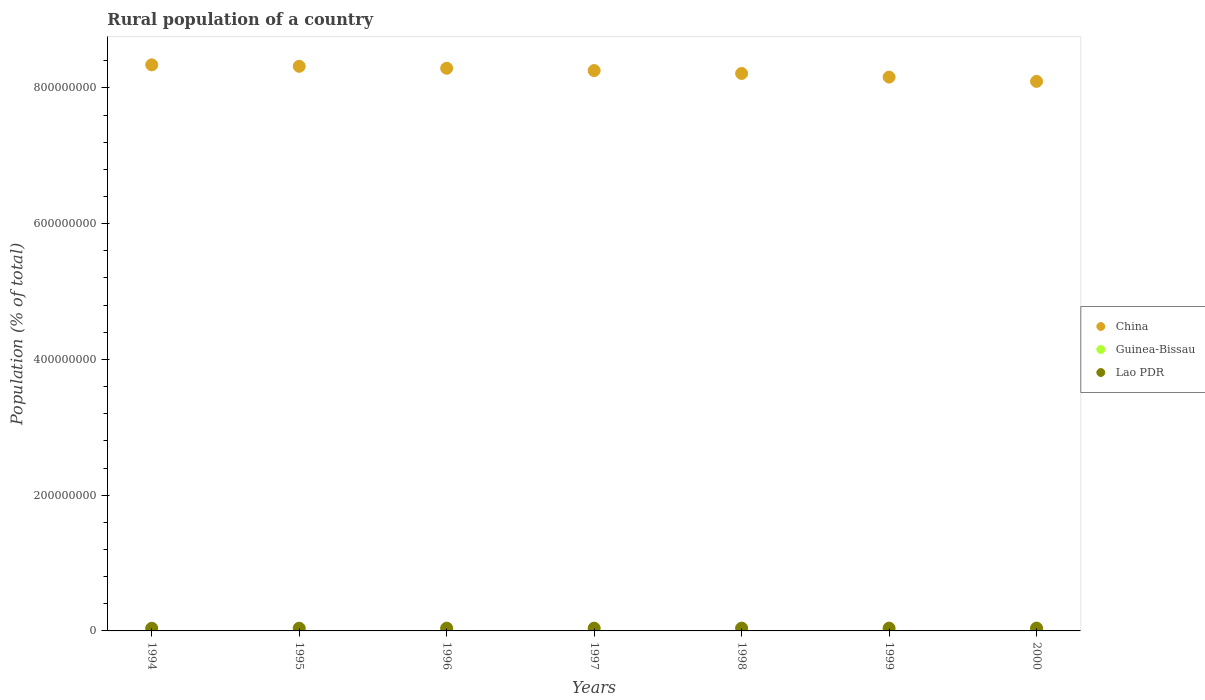Is the number of dotlines equal to the number of legend labels?
Offer a terse response. Yes. What is the rural population in China in 1999?
Your response must be concise. 8.16e+08. Across all years, what is the maximum rural population in Guinea-Bissau?
Keep it short and to the point. 8.33e+05. Across all years, what is the minimum rural population in Lao PDR?
Provide a short and direct response. 3.94e+06. In which year was the rural population in Lao PDR minimum?
Offer a very short reply. 1994. What is the total rural population in China in the graph?
Your response must be concise. 5.77e+09. What is the difference between the rural population in China in 1996 and that in 1999?
Ensure brevity in your answer.  1.30e+07. What is the difference between the rural population in Lao PDR in 1998 and the rural population in China in 1999?
Provide a short and direct response. -8.12e+08. What is the average rural population in Guinea-Bissau per year?
Ensure brevity in your answer.  8.11e+05. In the year 1994, what is the difference between the rural population in Guinea-Bissau and rural population in China?
Ensure brevity in your answer.  -8.33e+08. In how many years, is the rural population in China greater than 560000000 %?
Give a very brief answer. 7. What is the ratio of the rural population in Guinea-Bissau in 1998 to that in 2000?
Your answer should be very brief. 0.98. What is the difference between the highest and the second highest rural population in Lao PDR?
Provide a succinct answer. 1.58e+04. What is the difference between the highest and the lowest rural population in Guinea-Bissau?
Ensure brevity in your answer.  4.62e+04. Is the sum of the rural population in Guinea-Bissau in 1997 and 1999 greater than the maximum rural population in China across all years?
Keep it short and to the point. No. Is it the case that in every year, the sum of the rural population in Lao PDR and rural population in Guinea-Bissau  is greater than the rural population in China?
Your response must be concise. No. Does the rural population in Lao PDR monotonically increase over the years?
Make the answer very short. Yes. Is the rural population in Lao PDR strictly less than the rural population in Guinea-Bissau over the years?
Offer a terse response. No. How many dotlines are there?
Offer a terse response. 3. Does the graph contain grids?
Provide a succinct answer. No. Where does the legend appear in the graph?
Provide a short and direct response. Center right. What is the title of the graph?
Keep it short and to the point. Rural population of a country. Does "Tanzania" appear as one of the legend labels in the graph?
Give a very brief answer. No. What is the label or title of the Y-axis?
Your answer should be compact. Population (% of total). What is the Population (% of total) in China in 1994?
Make the answer very short. 8.34e+08. What is the Population (% of total) of Guinea-Bissau in 1994?
Offer a very short reply. 7.87e+05. What is the Population (% of total) of Lao PDR in 1994?
Provide a short and direct response. 3.94e+06. What is the Population (% of total) of China in 1995?
Offer a very short reply. 8.32e+08. What is the Population (% of total) in Guinea-Bissau in 1995?
Make the answer very short. 7.96e+05. What is the Population (% of total) of Lao PDR in 1995?
Ensure brevity in your answer.  4.01e+06. What is the Population (% of total) in China in 1996?
Your answer should be compact. 8.29e+08. What is the Population (% of total) of Guinea-Bissau in 1996?
Provide a succinct answer. 8.04e+05. What is the Population (% of total) in Lao PDR in 1996?
Provide a succinct answer. 4.06e+06. What is the Population (% of total) of China in 1997?
Your answer should be compact. 8.26e+08. What is the Population (% of total) of Guinea-Bissau in 1997?
Give a very brief answer. 8.11e+05. What is the Population (% of total) of Lao PDR in 1997?
Your answer should be compact. 4.10e+06. What is the Population (% of total) in China in 1998?
Your response must be concise. 8.21e+08. What is the Population (% of total) of Guinea-Bissau in 1998?
Your response must be concise. 8.19e+05. What is the Population (% of total) of Lao PDR in 1998?
Provide a succinct answer. 4.13e+06. What is the Population (% of total) of China in 1999?
Provide a short and direct response. 8.16e+08. What is the Population (% of total) of Guinea-Bissau in 1999?
Your answer should be very brief. 8.26e+05. What is the Population (% of total) in Lao PDR in 1999?
Offer a very short reply. 4.15e+06. What is the Population (% of total) in China in 2000?
Keep it short and to the point. 8.10e+08. What is the Population (% of total) of Guinea-Bissau in 2000?
Make the answer very short. 8.33e+05. What is the Population (% of total) of Lao PDR in 2000?
Give a very brief answer. 4.17e+06. Across all years, what is the maximum Population (% of total) of China?
Your answer should be very brief. 8.34e+08. Across all years, what is the maximum Population (% of total) in Guinea-Bissau?
Your answer should be very brief. 8.33e+05. Across all years, what is the maximum Population (% of total) of Lao PDR?
Your answer should be very brief. 4.17e+06. Across all years, what is the minimum Population (% of total) in China?
Offer a very short reply. 8.10e+08. Across all years, what is the minimum Population (% of total) in Guinea-Bissau?
Your response must be concise. 7.87e+05. Across all years, what is the minimum Population (% of total) of Lao PDR?
Give a very brief answer. 3.94e+06. What is the total Population (% of total) of China in the graph?
Ensure brevity in your answer.  5.77e+09. What is the total Population (% of total) of Guinea-Bissau in the graph?
Ensure brevity in your answer.  5.68e+06. What is the total Population (% of total) in Lao PDR in the graph?
Ensure brevity in your answer.  2.86e+07. What is the difference between the Population (% of total) in China in 1994 and that in 1995?
Your answer should be compact. 2.18e+06. What is the difference between the Population (% of total) in Guinea-Bissau in 1994 and that in 1995?
Your answer should be compact. -8394. What is the difference between the Population (% of total) in Lao PDR in 1994 and that in 1995?
Provide a short and direct response. -7.02e+04. What is the difference between the Population (% of total) in China in 1994 and that in 1996?
Your response must be concise. 5.04e+06. What is the difference between the Population (% of total) in Guinea-Bissau in 1994 and that in 1996?
Give a very brief answer. -1.65e+04. What is the difference between the Population (% of total) in Lao PDR in 1994 and that in 1996?
Provide a succinct answer. -1.17e+05. What is the difference between the Population (% of total) in China in 1994 and that in 1997?
Your response must be concise. 8.41e+06. What is the difference between the Population (% of total) in Guinea-Bissau in 1994 and that in 1997?
Your response must be concise. -2.43e+04. What is the difference between the Population (% of total) of Lao PDR in 1994 and that in 1997?
Give a very brief answer. -1.56e+05. What is the difference between the Population (% of total) of China in 1994 and that in 1998?
Your answer should be compact. 1.27e+07. What is the difference between the Population (% of total) of Guinea-Bissau in 1994 and that in 1998?
Keep it short and to the point. -3.19e+04. What is the difference between the Population (% of total) of Lao PDR in 1994 and that in 1998?
Offer a terse response. -1.87e+05. What is the difference between the Population (% of total) of China in 1994 and that in 1999?
Offer a terse response. 1.80e+07. What is the difference between the Population (% of total) in Guinea-Bissau in 1994 and that in 1999?
Make the answer very short. -3.92e+04. What is the difference between the Population (% of total) in Lao PDR in 1994 and that in 1999?
Provide a short and direct response. -2.10e+05. What is the difference between the Population (% of total) in China in 1994 and that in 2000?
Your answer should be very brief. 2.44e+07. What is the difference between the Population (% of total) of Guinea-Bissau in 1994 and that in 2000?
Offer a terse response. -4.62e+04. What is the difference between the Population (% of total) of Lao PDR in 1994 and that in 2000?
Your answer should be compact. -2.25e+05. What is the difference between the Population (% of total) in China in 1995 and that in 1996?
Offer a terse response. 2.86e+06. What is the difference between the Population (% of total) of Guinea-Bissau in 1995 and that in 1996?
Provide a succinct answer. -8104. What is the difference between the Population (% of total) of Lao PDR in 1995 and that in 1996?
Give a very brief answer. -4.72e+04. What is the difference between the Population (% of total) in China in 1995 and that in 1997?
Your answer should be compact. 6.23e+06. What is the difference between the Population (% of total) in Guinea-Bissau in 1995 and that in 1997?
Make the answer very short. -1.60e+04. What is the difference between the Population (% of total) in Lao PDR in 1995 and that in 1997?
Make the answer very short. -8.59e+04. What is the difference between the Population (% of total) in China in 1995 and that in 1998?
Ensure brevity in your answer.  1.05e+07. What is the difference between the Population (% of total) of Guinea-Bissau in 1995 and that in 1998?
Offer a very short reply. -2.35e+04. What is the difference between the Population (% of total) in Lao PDR in 1995 and that in 1998?
Ensure brevity in your answer.  -1.16e+05. What is the difference between the Population (% of total) of China in 1995 and that in 1999?
Your answer should be very brief. 1.59e+07. What is the difference between the Population (% of total) of Guinea-Bissau in 1995 and that in 1999?
Offer a terse response. -3.08e+04. What is the difference between the Population (% of total) in Lao PDR in 1995 and that in 1999?
Keep it short and to the point. -1.39e+05. What is the difference between the Population (% of total) in China in 1995 and that in 2000?
Provide a succinct answer. 2.22e+07. What is the difference between the Population (% of total) of Guinea-Bissau in 1995 and that in 2000?
Make the answer very short. -3.78e+04. What is the difference between the Population (% of total) in Lao PDR in 1995 and that in 2000?
Provide a succinct answer. -1.55e+05. What is the difference between the Population (% of total) of China in 1996 and that in 1997?
Provide a short and direct response. 3.37e+06. What is the difference between the Population (% of total) in Guinea-Bissau in 1996 and that in 1997?
Offer a terse response. -7846. What is the difference between the Population (% of total) of Lao PDR in 1996 and that in 1997?
Your answer should be very brief. -3.88e+04. What is the difference between the Population (% of total) of China in 1996 and that in 1998?
Keep it short and to the point. 7.63e+06. What is the difference between the Population (% of total) in Guinea-Bissau in 1996 and that in 1998?
Your answer should be compact. -1.54e+04. What is the difference between the Population (% of total) in Lao PDR in 1996 and that in 1998?
Your response must be concise. -6.93e+04. What is the difference between the Population (% of total) of China in 1996 and that in 1999?
Offer a very short reply. 1.30e+07. What is the difference between the Population (% of total) of Guinea-Bissau in 1996 and that in 1999?
Make the answer very short. -2.27e+04. What is the difference between the Population (% of total) in Lao PDR in 1996 and that in 1999?
Provide a succinct answer. -9.21e+04. What is the difference between the Population (% of total) in China in 1996 and that in 2000?
Offer a terse response. 1.93e+07. What is the difference between the Population (% of total) of Guinea-Bissau in 1996 and that in 2000?
Your response must be concise. -2.97e+04. What is the difference between the Population (% of total) in Lao PDR in 1996 and that in 2000?
Offer a terse response. -1.08e+05. What is the difference between the Population (% of total) in China in 1997 and that in 1998?
Offer a terse response. 4.26e+06. What is the difference between the Population (% of total) of Guinea-Bissau in 1997 and that in 1998?
Provide a succinct answer. -7565. What is the difference between the Population (% of total) in Lao PDR in 1997 and that in 1998?
Give a very brief answer. -3.05e+04. What is the difference between the Population (% of total) of China in 1997 and that in 1999?
Offer a very short reply. 9.62e+06. What is the difference between the Population (% of total) of Guinea-Bissau in 1997 and that in 1999?
Provide a succinct answer. -1.48e+04. What is the difference between the Population (% of total) of Lao PDR in 1997 and that in 1999?
Offer a very short reply. -5.33e+04. What is the difference between the Population (% of total) of China in 1997 and that in 2000?
Provide a short and direct response. 1.59e+07. What is the difference between the Population (% of total) in Guinea-Bissau in 1997 and that in 2000?
Ensure brevity in your answer.  -2.18e+04. What is the difference between the Population (% of total) in Lao PDR in 1997 and that in 2000?
Provide a succinct answer. -6.91e+04. What is the difference between the Population (% of total) of China in 1998 and that in 1999?
Ensure brevity in your answer.  5.36e+06. What is the difference between the Population (% of total) in Guinea-Bissau in 1998 and that in 1999?
Your answer should be very brief. -7273. What is the difference between the Population (% of total) in Lao PDR in 1998 and that in 1999?
Your answer should be compact. -2.28e+04. What is the difference between the Population (% of total) in China in 1998 and that in 2000?
Your answer should be compact. 1.17e+07. What is the difference between the Population (% of total) in Guinea-Bissau in 1998 and that in 2000?
Your answer should be very brief. -1.43e+04. What is the difference between the Population (% of total) of Lao PDR in 1998 and that in 2000?
Provide a succinct answer. -3.86e+04. What is the difference between the Population (% of total) of China in 1999 and that in 2000?
Keep it short and to the point. 6.32e+06. What is the difference between the Population (% of total) in Guinea-Bissau in 1999 and that in 2000?
Provide a short and direct response. -6979. What is the difference between the Population (% of total) of Lao PDR in 1999 and that in 2000?
Offer a very short reply. -1.58e+04. What is the difference between the Population (% of total) in China in 1994 and the Population (% of total) in Guinea-Bissau in 1995?
Your answer should be very brief. 8.33e+08. What is the difference between the Population (% of total) of China in 1994 and the Population (% of total) of Lao PDR in 1995?
Your response must be concise. 8.30e+08. What is the difference between the Population (% of total) of Guinea-Bissau in 1994 and the Population (% of total) of Lao PDR in 1995?
Make the answer very short. -3.23e+06. What is the difference between the Population (% of total) in China in 1994 and the Population (% of total) in Guinea-Bissau in 1996?
Your response must be concise. 8.33e+08. What is the difference between the Population (% of total) in China in 1994 and the Population (% of total) in Lao PDR in 1996?
Your response must be concise. 8.30e+08. What is the difference between the Population (% of total) in Guinea-Bissau in 1994 and the Population (% of total) in Lao PDR in 1996?
Make the answer very short. -3.27e+06. What is the difference between the Population (% of total) in China in 1994 and the Population (% of total) in Guinea-Bissau in 1997?
Ensure brevity in your answer.  8.33e+08. What is the difference between the Population (% of total) of China in 1994 and the Population (% of total) of Lao PDR in 1997?
Keep it short and to the point. 8.30e+08. What is the difference between the Population (% of total) in Guinea-Bissau in 1994 and the Population (% of total) in Lao PDR in 1997?
Your answer should be very brief. -3.31e+06. What is the difference between the Population (% of total) of China in 1994 and the Population (% of total) of Guinea-Bissau in 1998?
Give a very brief answer. 8.33e+08. What is the difference between the Population (% of total) in China in 1994 and the Population (% of total) in Lao PDR in 1998?
Your answer should be compact. 8.30e+08. What is the difference between the Population (% of total) in Guinea-Bissau in 1994 and the Population (% of total) in Lao PDR in 1998?
Ensure brevity in your answer.  -3.34e+06. What is the difference between the Population (% of total) of China in 1994 and the Population (% of total) of Guinea-Bissau in 1999?
Make the answer very short. 8.33e+08. What is the difference between the Population (% of total) of China in 1994 and the Population (% of total) of Lao PDR in 1999?
Keep it short and to the point. 8.30e+08. What is the difference between the Population (% of total) in Guinea-Bissau in 1994 and the Population (% of total) in Lao PDR in 1999?
Provide a short and direct response. -3.37e+06. What is the difference between the Population (% of total) in China in 1994 and the Population (% of total) in Guinea-Bissau in 2000?
Your response must be concise. 8.33e+08. What is the difference between the Population (% of total) in China in 1994 and the Population (% of total) in Lao PDR in 2000?
Your answer should be compact. 8.30e+08. What is the difference between the Population (% of total) in Guinea-Bissau in 1994 and the Population (% of total) in Lao PDR in 2000?
Offer a terse response. -3.38e+06. What is the difference between the Population (% of total) of China in 1995 and the Population (% of total) of Guinea-Bissau in 1996?
Provide a short and direct response. 8.31e+08. What is the difference between the Population (% of total) in China in 1995 and the Population (% of total) in Lao PDR in 1996?
Ensure brevity in your answer.  8.28e+08. What is the difference between the Population (% of total) of Guinea-Bissau in 1995 and the Population (% of total) of Lao PDR in 1996?
Your response must be concise. -3.27e+06. What is the difference between the Population (% of total) in China in 1995 and the Population (% of total) in Guinea-Bissau in 1997?
Your response must be concise. 8.31e+08. What is the difference between the Population (% of total) of China in 1995 and the Population (% of total) of Lao PDR in 1997?
Keep it short and to the point. 8.28e+08. What is the difference between the Population (% of total) of Guinea-Bissau in 1995 and the Population (% of total) of Lao PDR in 1997?
Provide a succinct answer. -3.30e+06. What is the difference between the Population (% of total) in China in 1995 and the Population (% of total) in Guinea-Bissau in 1998?
Offer a terse response. 8.31e+08. What is the difference between the Population (% of total) of China in 1995 and the Population (% of total) of Lao PDR in 1998?
Keep it short and to the point. 8.28e+08. What is the difference between the Population (% of total) of Guinea-Bissau in 1995 and the Population (% of total) of Lao PDR in 1998?
Provide a short and direct response. -3.33e+06. What is the difference between the Population (% of total) in China in 1995 and the Population (% of total) in Guinea-Bissau in 1999?
Keep it short and to the point. 8.31e+08. What is the difference between the Population (% of total) in China in 1995 and the Population (% of total) in Lao PDR in 1999?
Offer a very short reply. 8.28e+08. What is the difference between the Population (% of total) in Guinea-Bissau in 1995 and the Population (% of total) in Lao PDR in 1999?
Keep it short and to the point. -3.36e+06. What is the difference between the Population (% of total) in China in 1995 and the Population (% of total) in Guinea-Bissau in 2000?
Provide a short and direct response. 8.31e+08. What is the difference between the Population (% of total) of China in 1995 and the Population (% of total) of Lao PDR in 2000?
Your response must be concise. 8.28e+08. What is the difference between the Population (% of total) of Guinea-Bissau in 1995 and the Population (% of total) of Lao PDR in 2000?
Provide a short and direct response. -3.37e+06. What is the difference between the Population (% of total) of China in 1996 and the Population (% of total) of Guinea-Bissau in 1997?
Make the answer very short. 8.28e+08. What is the difference between the Population (% of total) in China in 1996 and the Population (% of total) in Lao PDR in 1997?
Your answer should be compact. 8.25e+08. What is the difference between the Population (% of total) in Guinea-Bissau in 1996 and the Population (% of total) in Lao PDR in 1997?
Your answer should be compact. -3.30e+06. What is the difference between the Population (% of total) in China in 1996 and the Population (% of total) in Guinea-Bissau in 1998?
Your answer should be compact. 8.28e+08. What is the difference between the Population (% of total) of China in 1996 and the Population (% of total) of Lao PDR in 1998?
Your answer should be compact. 8.25e+08. What is the difference between the Population (% of total) of Guinea-Bissau in 1996 and the Population (% of total) of Lao PDR in 1998?
Provide a short and direct response. -3.33e+06. What is the difference between the Population (% of total) of China in 1996 and the Population (% of total) of Guinea-Bissau in 1999?
Your response must be concise. 8.28e+08. What is the difference between the Population (% of total) of China in 1996 and the Population (% of total) of Lao PDR in 1999?
Ensure brevity in your answer.  8.25e+08. What is the difference between the Population (% of total) in Guinea-Bissau in 1996 and the Population (% of total) in Lao PDR in 1999?
Give a very brief answer. -3.35e+06. What is the difference between the Population (% of total) of China in 1996 and the Population (% of total) of Guinea-Bissau in 2000?
Ensure brevity in your answer.  8.28e+08. What is the difference between the Population (% of total) of China in 1996 and the Population (% of total) of Lao PDR in 2000?
Provide a short and direct response. 8.25e+08. What is the difference between the Population (% of total) of Guinea-Bissau in 1996 and the Population (% of total) of Lao PDR in 2000?
Make the answer very short. -3.37e+06. What is the difference between the Population (% of total) in China in 1997 and the Population (% of total) in Guinea-Bissau in 1998?
Give a very brief answer. 8.25e+08. What is the difference between the Population (% of total) in China in 1997 and the Population (% of total) in Lao PDR in 1998?
Ensure brevity in your answer.  8.21e+08. What is the difference between the Population (% of total) of Guinea-Bissau in 1997 and the Population (% of total) of Lao PDR in 1998?
Your answer should be very brief. -3.32e+06. What is the difference between the Population (% of total) in China in 1997 and the Population (% of total) in Guinea-Bissau in 1999?
Ensure brevity in your answer.  8.25e+08. What is the difference between the Population (% of total) of China in 1997 and the Population (% of total) of Lao PDR in 1999?
Provide a short and direct response. 8.21e+08. What is the difference between the Population (% of total) in Guinea-Bissau in 1997 and the Population (% of total) in Lao PDR in 1999?
Offer a very short reply. -3.34e+06. What is the difference between the Population (% of total) in China in 1997 and the Population (% of total) in Guinea-Bissau in 2000?
Provide a succinct answer. 8.25e+08. What is the difference between the Population (% of total) of China in 1997 and the Population (% of total) of Lao PDR in 2000?
Your response must be concise. 8.21e+08. What is the difference between the Population (% of total) of Guinea-Bissau in 1997 and the Population (% of total) of Lao PDR in 2000?
Ensure brevity in your answer.  -3.36e+06. What is the difference between the Population (% of total) of China in 1998 and the Population (% of total) of Guinea-Bissau in 1999?
Your response must be concise. 8.21e+08. What is the difference between the Population (% of total) in China in 1998 and the Population (% of total) in Lao PDR in 1999?
Your response must be concise. 8.17e+08. What is the difference between the Population (% of total) in Guinea-Bissau in 1998 and the Population (% of total) in Lao PDR in 1999?
Give a very brief answer. -3.33e+06. What is the difference between the Population (% of total) in China in 1998 and the Population (% of total) in Guinea-Bissau in 2000?
Provide a short and direct response. 8.20e+08. What is the difference between the Population (% of total) of China in 1998 and the Population (% of total) of Lao PDR in 2000?
Give a very brief answer. 8.17e+08. What is the difference between the Population (% of total) in Guinea-Bissau in 1998 and the Population (% of total) in Lao PDR in 2000?
Provide a short and direct response. -3.35e+06. What is the difference between the Population (% of total) of China in 1999 and the Population (% of total) of Guinea-Bissau in 2000?
Your answer should be compact. 8.15e+08. What is the difference between the Population (% of total) of China in 1999 and the Population (% of total) of Lao PDR in 2000?
Offer a terse response. 8.12e+08. What is the difference between the Population (% of total) in Guinea-Bissau in 1999 and the Population (% of total) in Lao PDR in 2000?
Offer a terse response. -3.34e+06. What is the average Population (% of total) in China per year?
Offer a very short reply. 8.24e+08. What is the average Population (% of total) in Guinea-Bissau per year?
Make the answer very short. 8.11e+05. What is the average Population (% of total) of Lao PDR per year?
Offer a terse response. 4.08e+06. In the year 1994, what is the difference between the Population (% of total) of China and Population (% of total) of Guinea-Bissau?
Keep it short and to the point. 8.33e+08. In the year 1994, what is the difference between the Population (% of total) of China and Population (% of total) of Lao PDR?
Give a very brief answer. 8.30e+08. In the year 1994, what is the difference between the Population (% of total) in Guinea-Bissau and Population (% of total) in Lao PDR?
Ensure brevity in your answer.  -3.16e+06. In the year 1995, what is the difference between the Population (% of total) in China and Population (% of total) in Guinea-Bissau?
Your response must be concise. 8.31e+08. In the year 1995, what is the difference between the Population (% of total) of China and Population (% of total) of Lao PDR?
Your answer should be compact. 8.28e+08. In the year 1995, what is the difference between the Population (% of total) in Guinea-Bissau and Population (% of total) in Lao PDR?
Offer a terse response. -3.22e+06. In the year 1996, what is the difference between the Population (% of total) of China and Population (% of total) of Guinea-Bissau?
Your answer should be very brief. 8.28e+08. In the year 1996, what is the difference between the Population (% of total) of China and Population (% of total) of Lao PDR?
Your answer should be very brief. 8.25e+08. In the year 1996, what is the difference between the Population (% of total) of Guinea-Bissau and Population (% of total) of Lao PDR?
Offer a very short reply. -3.26e+06. In the year 1997, what is the difference between the Population (% of total) in China and Population (% of total) in Guinea-Bissau?
Your answer should be very brief. 8.25e+08. In the year 1997, what is the difference between the Population (% of total) of China and Population (% of total) of Lao PDR?
Provide a succinct answer. 8.21e+08. In the year 1997, what is the difference between the Population (% of total) in Guinea-Bissau and Population (% of total) in Lao PDR?
Keep it short and to the point. -3.29e+06. In the year 1998, what is the difference between the Population (% of total) of China and Population (% of total) of Guinea-Bissau?
Offer a terse response. 8.21e+08. In the year 1998, what is the difference between the Population (% of total) of China and Population (% of total) of Lao PDR?
Your answer should be compact. 8.17e+08. In the year 1998, what is the difference between the Population (% of total) of Guinea-Bissau and Population (% of total) of Lao PDR?
Keep it short and to the point. -3.31e+06. In the year 1999, what is the difference between the Population (% of total) in China and Population (% of total) in Guinea-Bissau?
Your response must be concise. 8.15e+08. In the year 1999, what is the difference between the Population (% of total) of China and Population (% of total) of Lao PDR?
Give a very brief answer. 8.12e+08. In the year 1999, what is the difference between the Population (% of total) in Guinea-Bissau and Population (% of total) in Lao PDR?
Offer a terse response. -3.33e+06. In the year 2000, what is the difference between the Population (% of total) of China and Population (% of total) of Guinea-Bissau?
Your answer should be compact. 8.09e+08. In the year 2000, what is the difference between the Population (% of total) of China and Population (% of total) of Lao PDR?
Make the answer very short. 8.05e+08. In the year 2000, what is the difference between the Population (% of total) in Guinea-Bissau and Population (% of total) in Lao PDR?
Provide a short and direct response. -3.34e+06. What is the ratio of the Population (% of total) of Guinea-Bissau in 1994 to that in 1995?
Your response must be concise. 0.99. What is the ratio of the Population (% of total) of Lao PDR in 1994 to that in 1995?
Your answer should be very brief. 0.98. What is the ratio of the Population (% of total) in Guinea-Bissau in 1994 to that in 1996?
Provide a succinct answer. 0.98. What is the ratio of the Population (% of total) of Lao PDR in 1994 to that in 1996?
Give a very brief answer. 0.97. What is the ratio of the Population (% of total) of China in 1994 to that in 1997?
Your answer should be compact. 1.01. What is the ratio of the Population (% of total) in Guinea-Bissau in 1994 to that in 1997?
Your response must be concise. 0.97. What is the ratio of the Population (% of total) in Lao PDR in 1994 to that in 1997?
Provide a succinct answer. 0.96. What is the ratio of the Population (% of total) of China in 1994 to that in 1998?
Provide a succinct answer. 1.02. What is the ratio of the Population (% of total) of Guinea-Bissau in 1994 to that in 1998?
Provide a short and direct response. 0.96. What is the ratio of the Population (% of total) in Lao PDR in 1994 to that in 1998?
Ensure brevity in your answer.  0.95. What is the ratio of the Population (% of total) in China in 1994 to that in 1999?
Ensure brevity in your answer.  1.02. What is the ratio of the Population (% of total) of Guinea-Bissau in 1994 to that in 1999?
Offer a terse response. 0.95. What is the ratio of the Population (% of total) in Lao PDR in 1994 to that in 1999?
Your answer should be compact. 0.95. What is the ratio of the Population (% of total) of China in 1994 to that in 2000?
Ensure brevity in your answer.  1.03. What is the ratio of the Population (% of total) in Guinea-Bissau in 1994 to that in 2000?
Ensure brevity in your answer.  0.94. What is the ratio of the Population (% of total) of Lao PDR in 1994 to that in 2000?
Offer a terse response. 0.95. What is the ratio of the Population (% of total) in China in 1995 to that in 1996?
Offer a very short reply. 1. What is the ratio of the Population (% of total) of Guinea-Bissau in 1995 to that in 1996?
Provide a succinct answer. 0.99. What is the ratio of the Population (% of total) of Lao PDR in 1995 to that in 1996?
Offer a very short reply. 0.99. What is the ratio of the Population (% of total) in China in 1995 to that in 1997?
Keep it short and to the point. 1.01. What is the ratio of the Population (% of total) of Guinea-Bissau in 1995 to that in 1997?
Offer a very short reply. 0.98. What is the ratio of the Population (% of total) in Lao PDR in 1995 to that in 1997?
Provide a succinct answer. 0.98. What is the ratio of the Population (% of total) in China in 1995 to that in 1998?
Offer a terse response. 1.01. What is the ratio of the Population (% of total) in Guinea-Bissau in 1995 to that in 1998?
Provide a succinct answer. 0.97. What is the ratio of the Population (% of total) in Lao PDR in 1995 to that in 1998?
Your response must be concise. 0.97. What is the ratio of the Population (% of total) of China in 1995 to that in 1999?
Give a very brief answer. 1.02. What is the ratio of the Population (% of total) of Guinea-Bissau in 1995 to that in 1999?
Provide a succinct answer. 0.96. What is the ratio of the Population (% of total) of Lao PDR in 1995 to that in 1999?
Give a very brief answer. 0.97. What is the ratio of the Population (% of total) of China in 1995 to that in 2000?
Your answer should be compact. 1.03. What is the ratio of the Population (% of total) in Guinea-Bissau in 1995 to that in 2000?
Your answer should be very brief. 0.95. What is the ratio of the Population (% of total) of Lao PDR in 1995 to that in 2000?
Your answer should be compact. 0.96. What is the ratio of the Population (% of total) of Guinea-Bissau in 1996 to that in 1997?
Your answer should be compact. 0.99. What is the ratio of the Population (% of total) in China in 1996 to that in 1998?
Keep it short and to the point. 1.01. What is the ratio of the Population (% of total) of Guinea-Bissau in 1996 to that in 1998?
Make the answer very short. 0.98. What is the ratio of the Population (% of total) in Lao PDR in 1996 to that in 1998?
Your answer should be compact. 0.98. What is the ratio of the Population (% of total) of China in 1996 to that in 1999?
Ensure brevity in your answer.  1.02. What is the ratio of the Population (% of total) in Guinea-Bissau in 1996 to that in 1999?
Keep it short and to the point. 0.97. What is the ratio of the Population (% of total) of Lao PDR in 1996 to that in 1999?
Your answer should be compact. 0.98. What is the ratio of the Population (% of total) in China in 1996 to that in 2000?
Give a very brief answer. 1.02. What is the ratio of the Population (% of total) in Guinea-Bissau in 1996 to that in 2000?
Offer a very short reply. 0.96. What is the ratio of the Population (% of total) of Lao PDR in 1996 to that in 2000?
Offer a terse response. 0.97. What is the ratio of the Population (% of total) in Lao PDR in 1997 to that in 1998?
Make the answer very short. 0.99. What is the ratio of the Population (% of total) in China in 1997 to that in 1999?
Offer a terse response. 1.01. What is the ratio of the Population (% of total) of Guinea-Bissau in 1997 to that in 1999?
Offer a very short reply. 0.98. What is the ratio of the Population (% of total) in Lao PDR in 1997 to that in 1999?
Offer a very short reply. 0.99. What is the ratio of the Population (% of total) in China in 1997 to that in 2000?
Your answer should be compact. 1.02. What is the ratio of the Population (% of total) of Guinea-Bissau in 1997 to that in 2000?
Your answer should be very brief. 0.97. What is the ratio of the Population (% of total) of Lao PDR in 1997 to that in 2000?
Your answer should be compact. 0.98. What is the ratio of the Population (% of total) of China in 1998 to that in 1999?
Provide a short and direct response. 1.01. What is the ratio of the Population (% of total) of China in 1998 to that in 2000?
Your response must be concise. 1.01. What is the ratio of the Population (% of total) in Guinea-Bissau in 1998 to that in 2000?
Your answer should be very brief. 0.98. What is the ratio of the Population (% of total) of Lao PDR in 1998 to that in 2000?
Your answer should be compact. 0.99. What is the ratio of the Population (% of total) in Guinea-Bissau in 1999 to that in 2000?
Provide a succinct answer. 0.99. What is the ratio of the Population (% of total) in Lao PDR in 1999 to that in 2000?
Provide a succinct answer. 1. What is the difference between the highest and the second highest Population (% of total) of China?
Provide a succinct answer. 2.18e+06. What is the difference between the highest and the second highest Population (% of total) of Guinea-Bissau?
Ensure brevity in your answer.  6979. What is the difference between the highest and the second highest Population (% of total) in Lao PDR?
Offer a terse response. 1.58e+04. What is the difference between the highest and the lowest Population (% of total) of China?
Offer a very short reply. 2.44e+07. What is the difference between the highest and the lowest Population (% of total) in Guinea-Bissau?
Your answer should be very brief. 4.62e+04. What is the difference between the highest and the lowest Population (% of total) of Lao PDR?
Provide a succinct answer. 2.25e+05. 